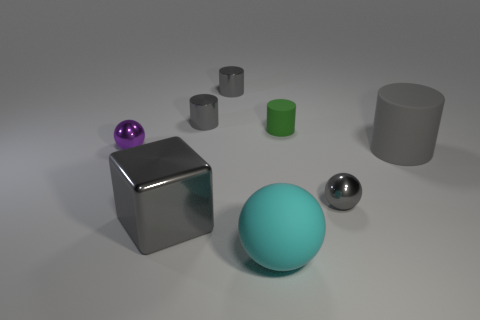What size is the ball that is in front of the big block that is left of the large rubber object right of the large cyan object?
Keep it short and to the point. Large. What material is the block that is the same size as the cyan sphere?
Make the answer very short. Metal. Are there any gray rubber cylinders that have the same size as the cyan rubber ball?
Provide a succinct answer. Yes. Does the large gray shiny object have the same shape as the small green matte thing?
Offer a very short reply. No. There is a small metallic object that is in front of the large rubber object behind the tiny gray metallic ball; is there a big shiny thing that is in front of it?
Ensure brevity in your answer.  Yes. What number of other objects are there of the same color as the small rubber cylinder?
Your answer should be very brief. 0. There is a metallic ball on the right side of the large gray metal block; is it the same size as the purple ball that is behind the big metallic object?
Provide a short and direct response. Yes. Is the number of large matte balls behind the gray rubber cylinder the same as the number of gray cylinders on the left side of the small green rubber object?
Offer a terse response. No. Is there any other thing that is made of the same material as the tiny gray ball?
Offer a very short reply. Yes. There is a cyan ball; is it the same size as the object that is to the left of the gray metal block?
Your answer should be very brief. No. 